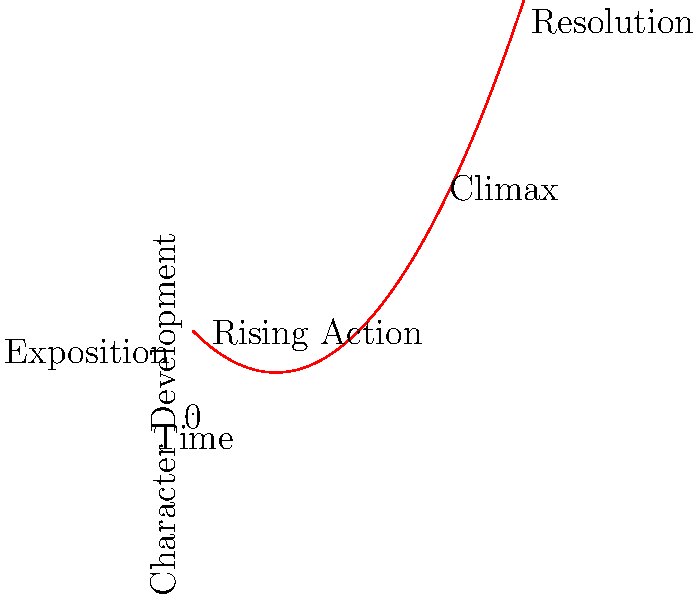In George Kay's screenwriting style, how does the character arc progression depicted in the graph relate to the narrative structure of a typical screenplay? To answer this question, let's analyze the graph in relation to George Kay's screenwriting techniques and the standard narrative structure:

1. The x-axis represents time, while the y-axis represents character development.

2. The curve starts at the "Exposition" point, which is relatively low on the y-axis. This aligns with Kay's approach of introducing characters in their ordinary world.

3. As we move along the x-axis, we enter the "Rising Action" phase. The curve shows a gradual increase, indicating character growth and challenges. This reflects Kay's tendency to slowly build tension and complexity in his characters.

4. The steepest part of the curve leads to the "Climax" point. This sharp rise represents the most significant character development, often seen in Kay's work where characters face their biggest challenges and undergo transformative experiences.

5. After the climax, there's a slight downward slope towards "Resolution". This mirrors Kay's preference for allowing characters to settle into their new reality post-climax, often with a bittersweet or complex ending.

6. The overall parabolic shape of the curve represents a complete character journey, from initial state, through conflict and change, to a new equilibrium - a hallmark of Kay's character-driven narratives.

This graph effectively illustrates Kay's approach to character development throughout a screenplay, emphasizing gradual build-up, intense climax, and a nuanced resolution.
Answer: The graph mirrors Kay's character development style: gradual build-up, intense climax, and nuanced resolution. 